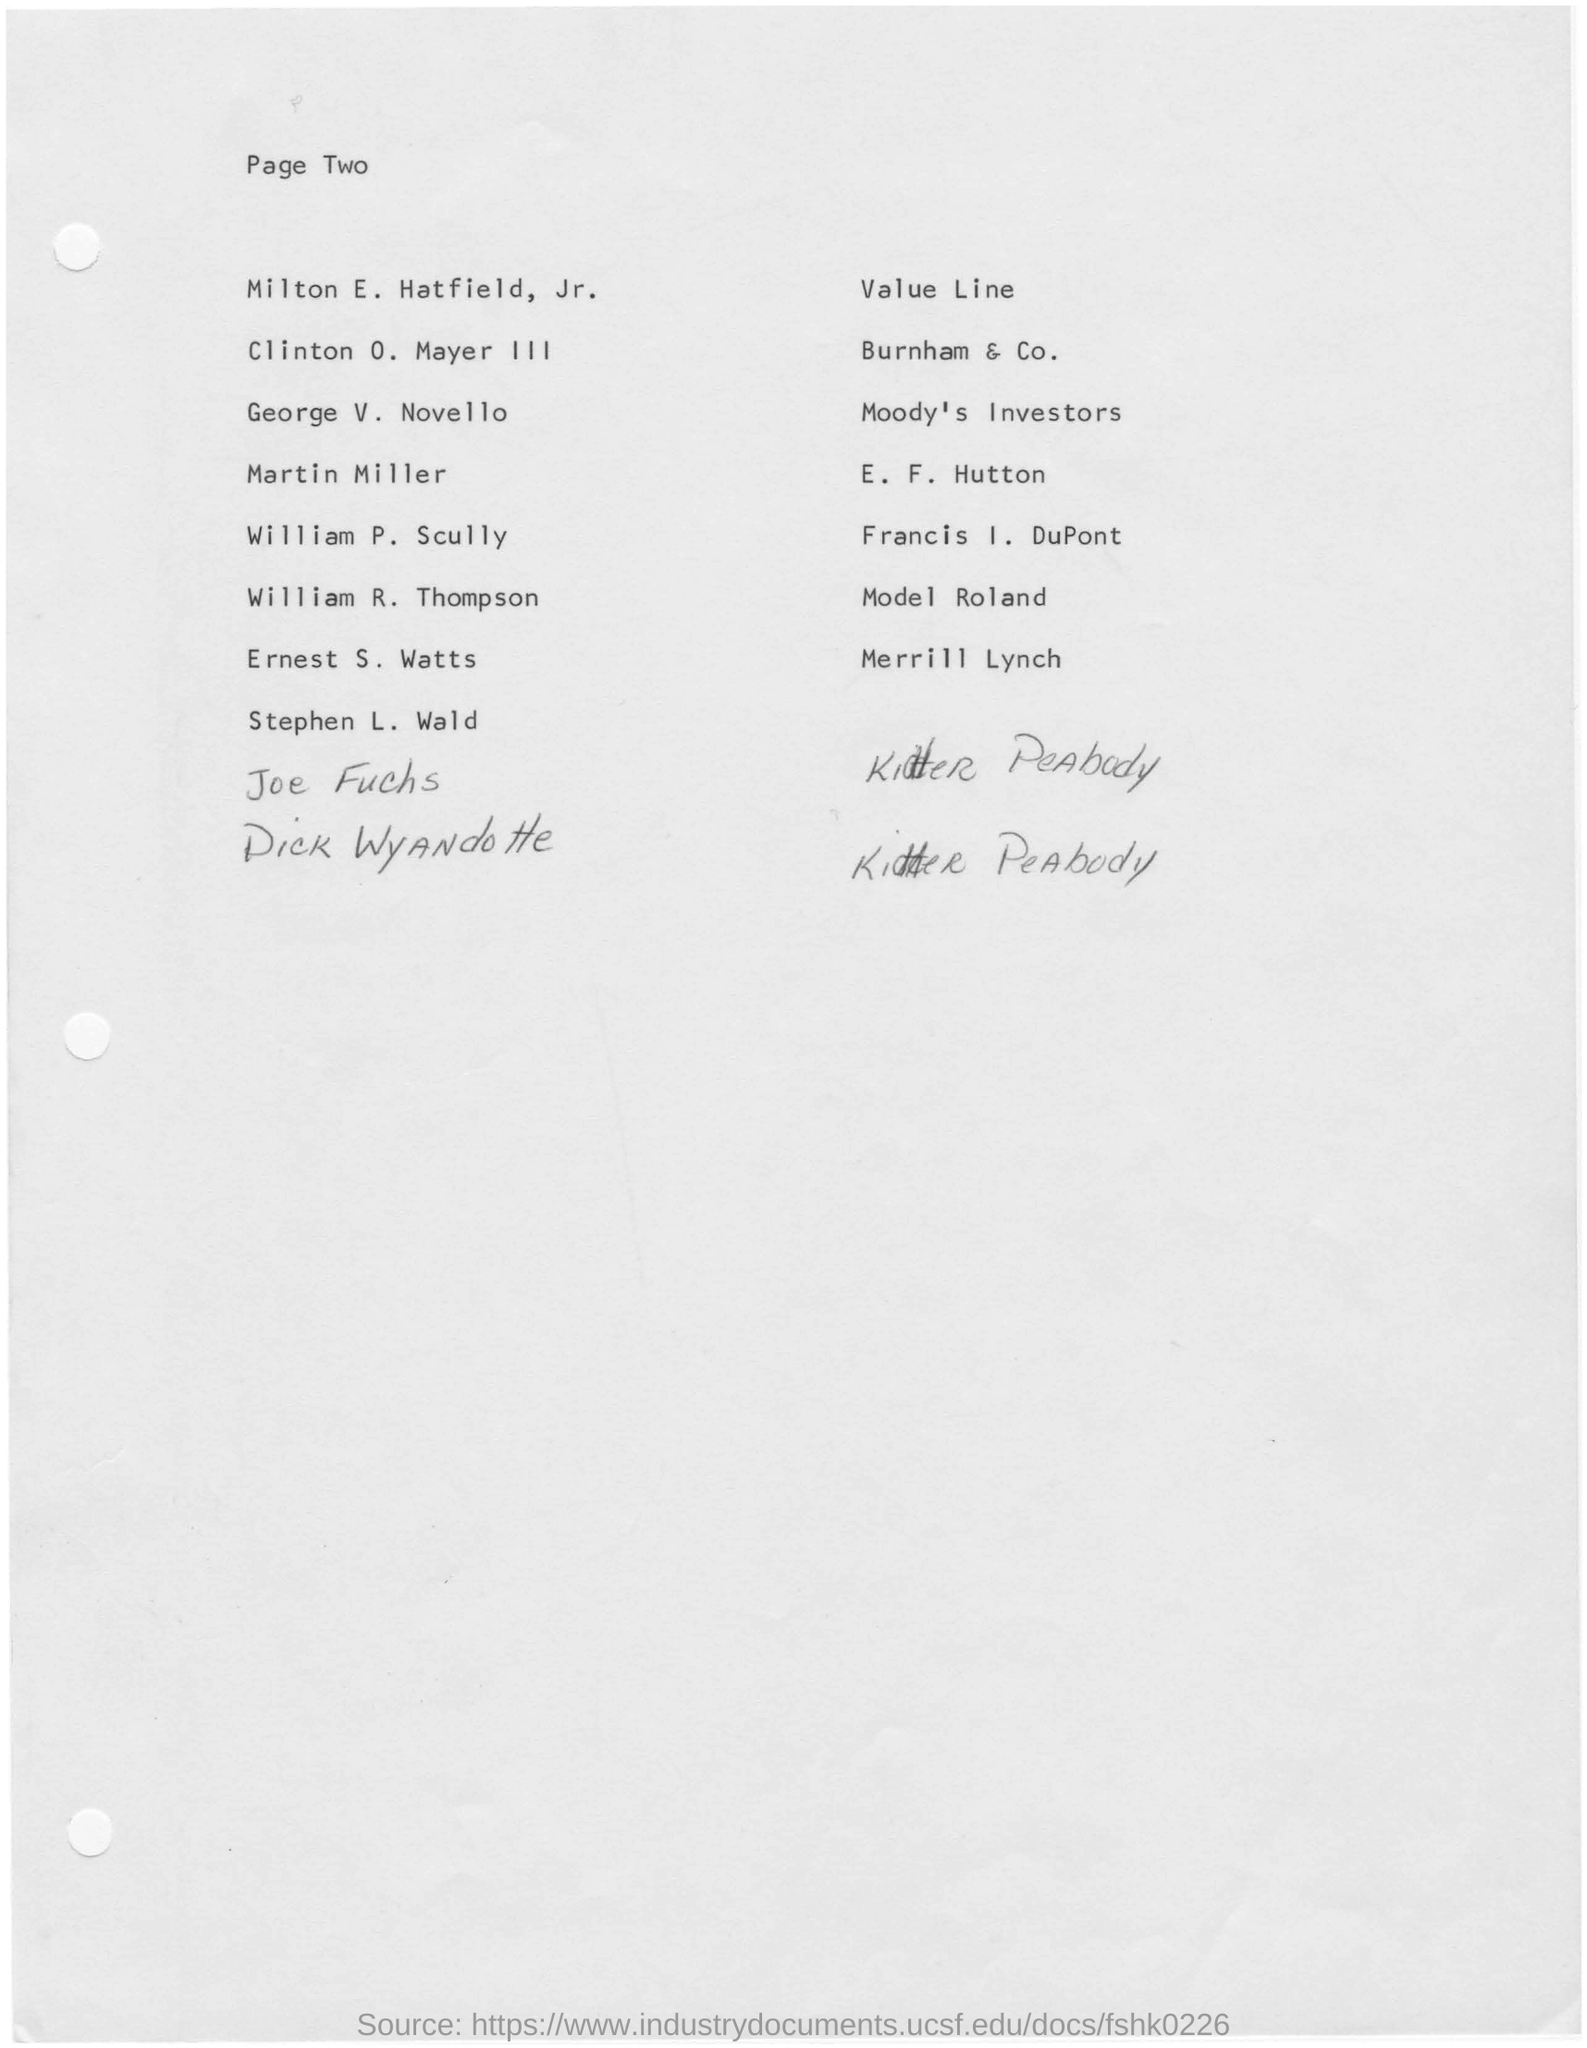Specify some key components in this picture. The top of the page reads 'Page Two', indicating that the current page is the second page of a document. 